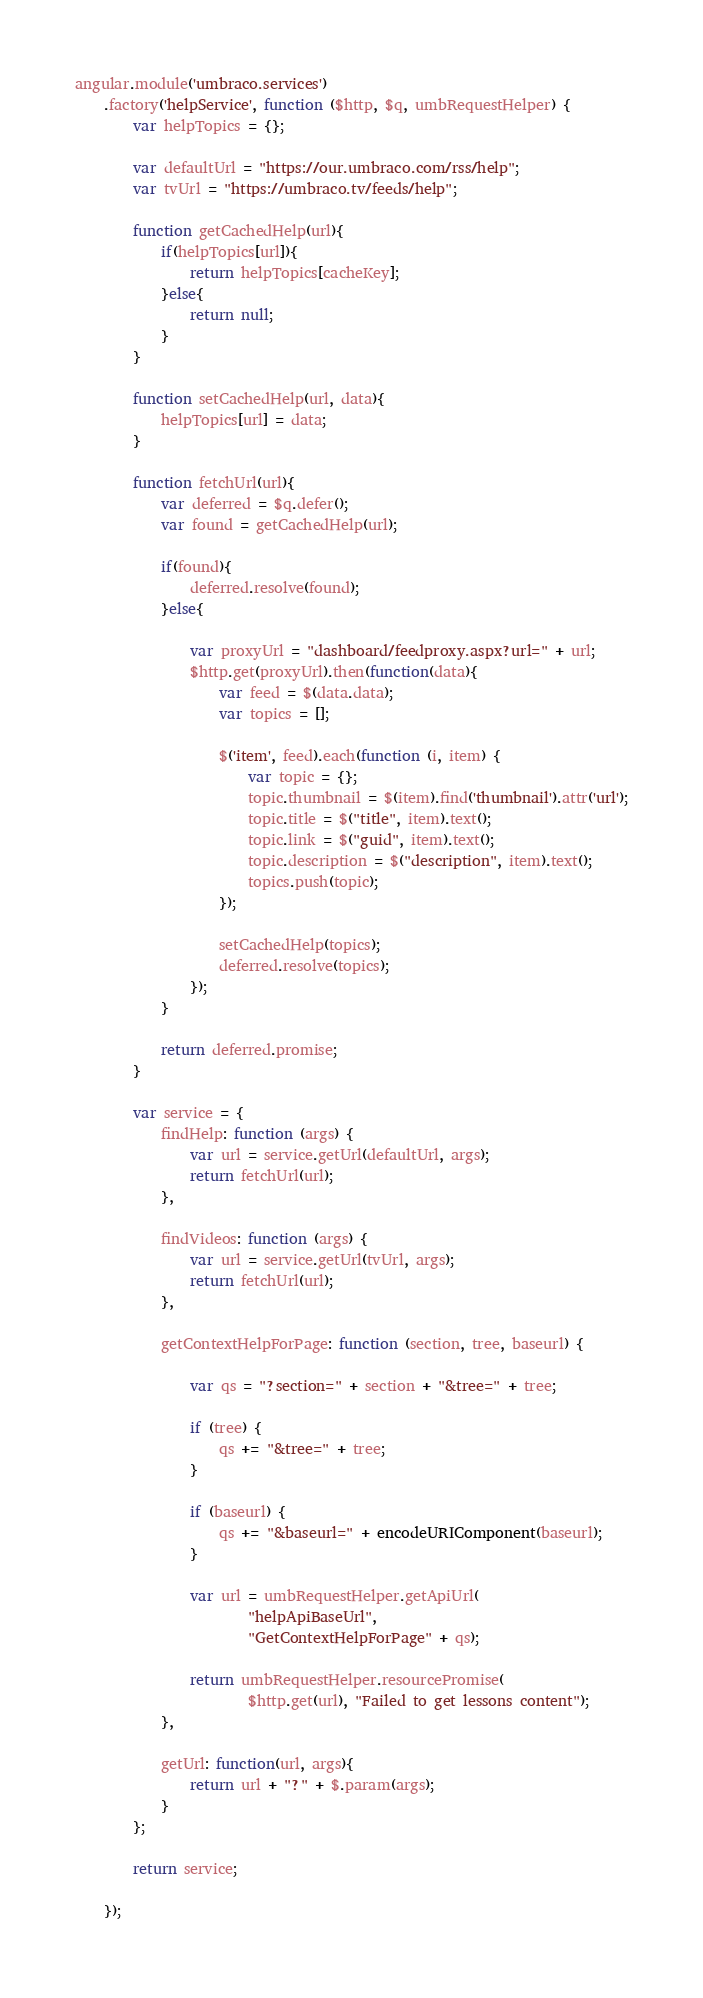Convert code to text. <code><loc_0><loc_0><loc_500><loc_500><_JavaScript_>angular.module('umbraco.services')
	.factory('helpService', function ($http, $q, umbRequestHelper) {
		var helpTopics = {};

		var defaultUrl = "https://our.umbraco.com/rss/help";
		var tvUrl = "https://umbraco.tv/feeds/help";

		function getCachedHelp(url){
			if(helpTopics[url]){
				return helpTopics[cacheKey];
			}else{
				return null;
			}
		}

		function setCachedHelp(url, data){
			helpTopics[url] = data;
		}

		function fetchUrl(url){
			var deferred = $q.defer();
			var found = getCachedHelp(url);

			if(found){
				deferred.resolve(found);
			}else{

				var proxyUrl = "dashboard/feedproxy.aspx?url=" + url; 
				$http.get(proxyUrl).then(function(data){
					var feed = $(data.data);
					var topics = [];

					$('item', feed).each(function (i, item) {
						var topic = {};
						topic.thumbnail = $(item).find('thumbnail').attr('url');
						topic.title = $("title", item).text();
						topic.link = $("guid", item).text();
						topic.description = $("description", item).text();
						topics.push(topic);
					});

					setCachedHelp(topics);
					deferred.resolve(topics);
				});
			}

			return deferred.promise;
		}

		var service = {
			findHelp: function (args) {
				var url = service.getUrl(defaultUrl, args);
				return fetchUrl(url);
			},

			findVideos: function (args) {
				var url = service.getUrl(tvUrl, args);
				return fetchUrl(url);
			},

			getContextHelpForPage: function (section, tree, baseurl) {

			    var qs = "?section=" + section + "&tree=" + tree;

			    if (tree) {
			        qs += "&tree=" + tree;
			    }

			    if (baseurl) {
			        qs += "&baseurl=" + encodeURIComponent(baseurl);
			    }

			    var url = umbRequestHelper.getApiUrl(
                        "helpApiBaseUrl",
                        "GetContextHelpForPage" + qs);

			    return umbRequestHelper.resourcePromise(
                        $http.get(url), "Failed to get lessons content");
			},

			getUrl: function(url, args){
				return url + "?" + $.param(args);
			}
		};

		return service;

	});
</code> 